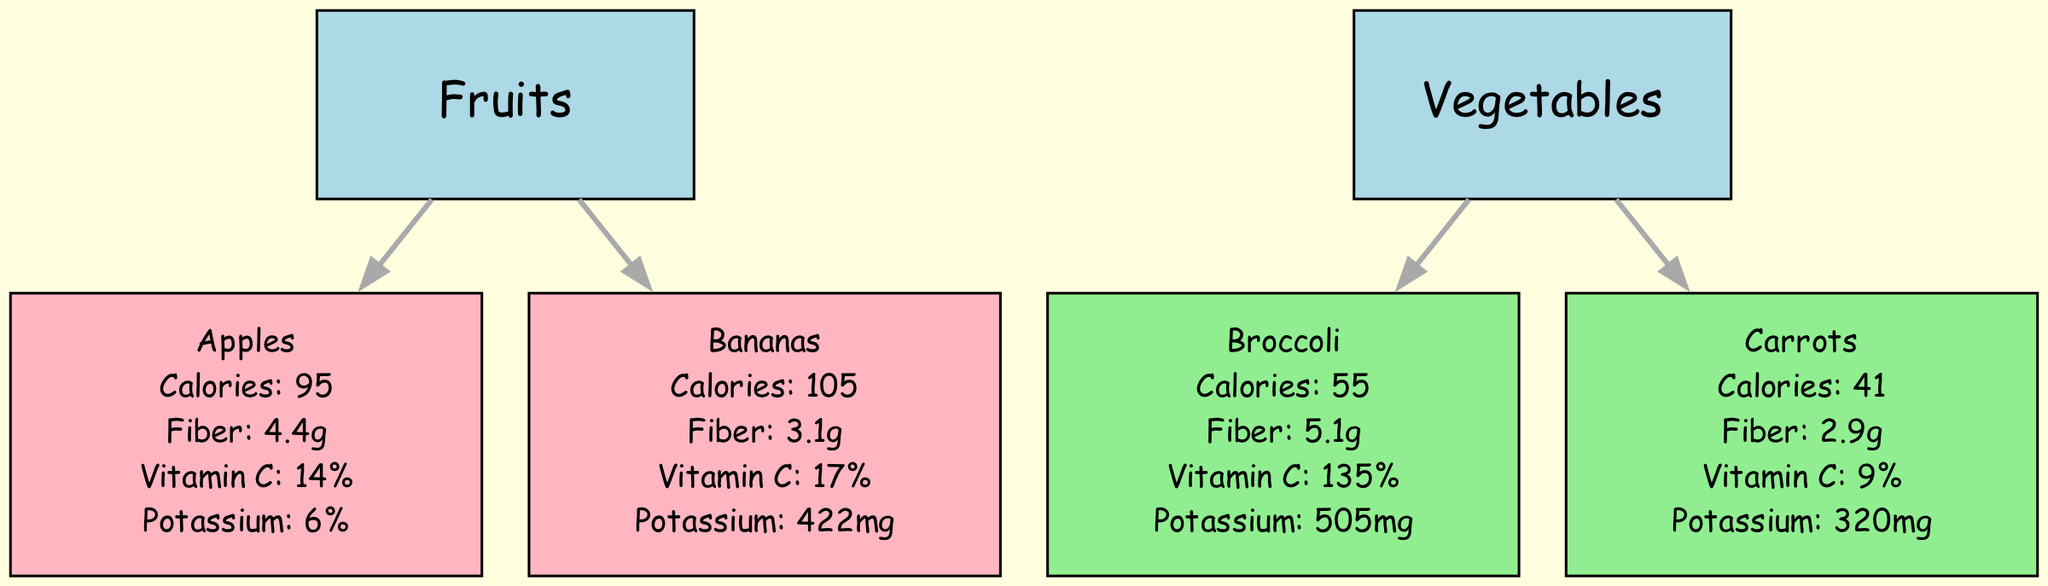What is the total number of fruits listed in the diagram? The diagram includes two nodes under the "Fruits" category: "Apples" and "Bananas". Adding these nodes together gives a total of 2 fruits.
Answer: 2 Which vegetable has the highest calorie content? Among the vegetables, "Broccoli" has 55 calories, while "Carrots" has 41 calories. Therefore, "Broccoli" has the highest calorie content.
Answer: Broccoli What percentage of Vitamin C does Carrots provide? Looking at the nutritional value for "Carrots", it shows that it provides 9% of Vitamin C. Therefore, the percentage is 9%.
Answer: 9% Which fruit has more fiber, Apples or Bananas? The nutritional value indicates that "Apples" have 4.4 grams of fiber and "Bananas" have 3.1 grams. Since 4.4 is greater than 3.1, "Apples" have more fiber.
Answer: Apples How many connections are there from Fruits to individual items? The connections indicate there are directed edges from "Fruits" to both "Apples" and "Bananas", totaling 2 connections.
Answer: 2 Which vegetable provides more potassium, Broccoli or Carrots? Comparing the potassium values, "Broccoli" provides 505mg while "Carrots" provides 320mg. Since 505mg is greater, "Broccoli" provides more potassium.
Answer: Broccoli What is the nutritional value of Bananas in terms of calories? Referring to the node for "Bananas", it states that the calories are 105. Therefore, the nutritional value for calories is 105.
Answer: 105 How is the nutritional value of Potassium represented for Apples? The nutritional value for "Apples" indicates it contains 6% of Potassium. This representation shows the proportion of potassium relative to daily intake.
Answer: 6% What type of graph is used to represent the nutritional value comparison? The diagram type is a directed graph as indicated in the initial description, which organizes the nutritional values hierarchically.
Answer: Directed graph 